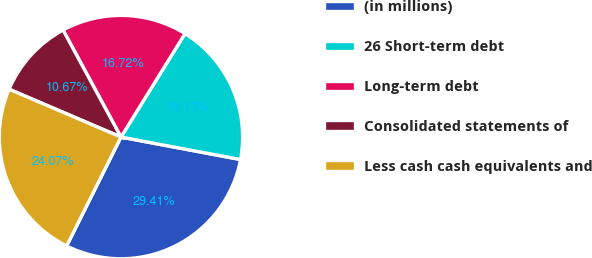Convert chart to OTSL. <chart><loc_0><loc_0><loc_500><loc_500><pie_chart><fcel>(in millions)<fcel>26 Short-term debt<fcel>Long-term debt<fcel>Consolidated statements of<fcel>Less cash cash equivalents and<nl><fcel>29.41%<fcel>19.13%<fcel>16.72%<fcel>10.67%<fcel>24.07%<nl></chart> 